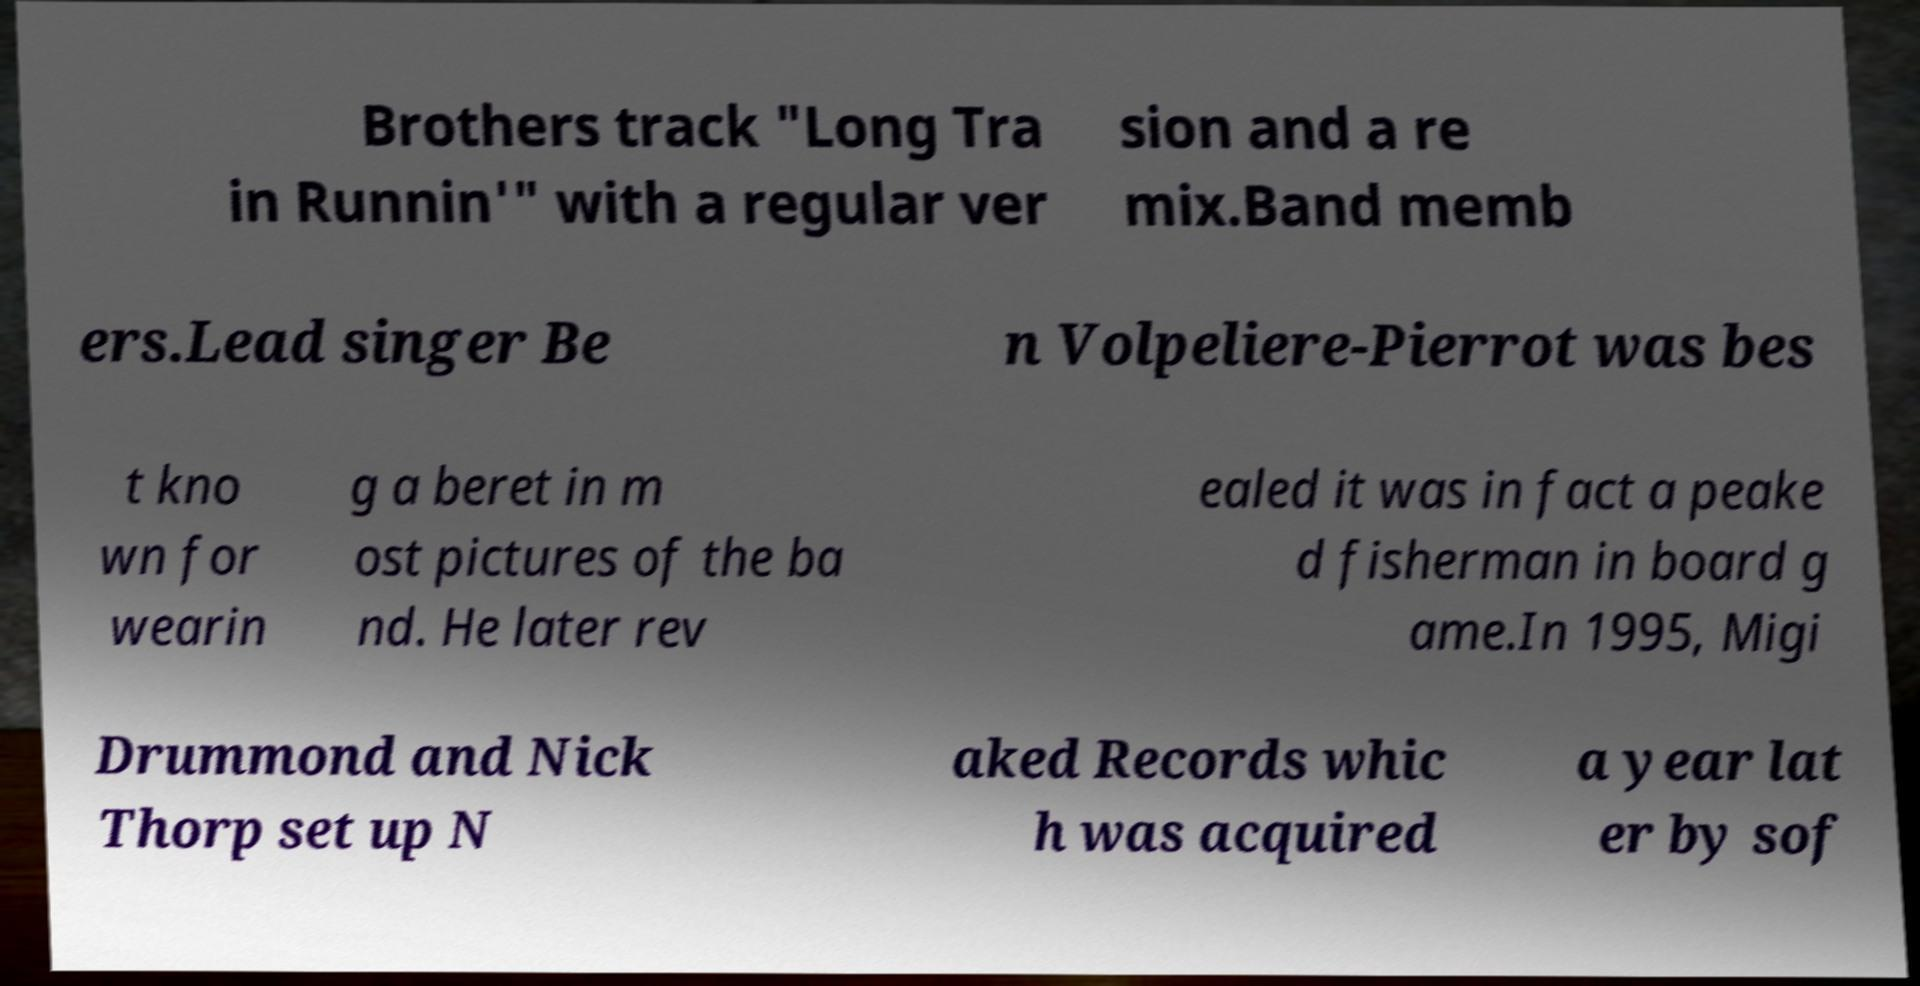Please identify and transcribe the text found in this image. Brothers track "Long Tra in Runnin'" with a regular ver sion and a re mix.Band memb ers.Lead singer Be n Volpeliere-Pierrot was bes t kno wn for wearin g a beret in m ost pictures of the ba nd. He later rev ealed it was in fact a peake d fisherman in board g ame.In 1995, Migi Drummond and Nick Thorp set up N aked Records whic h was acquired a year lat er by sof 